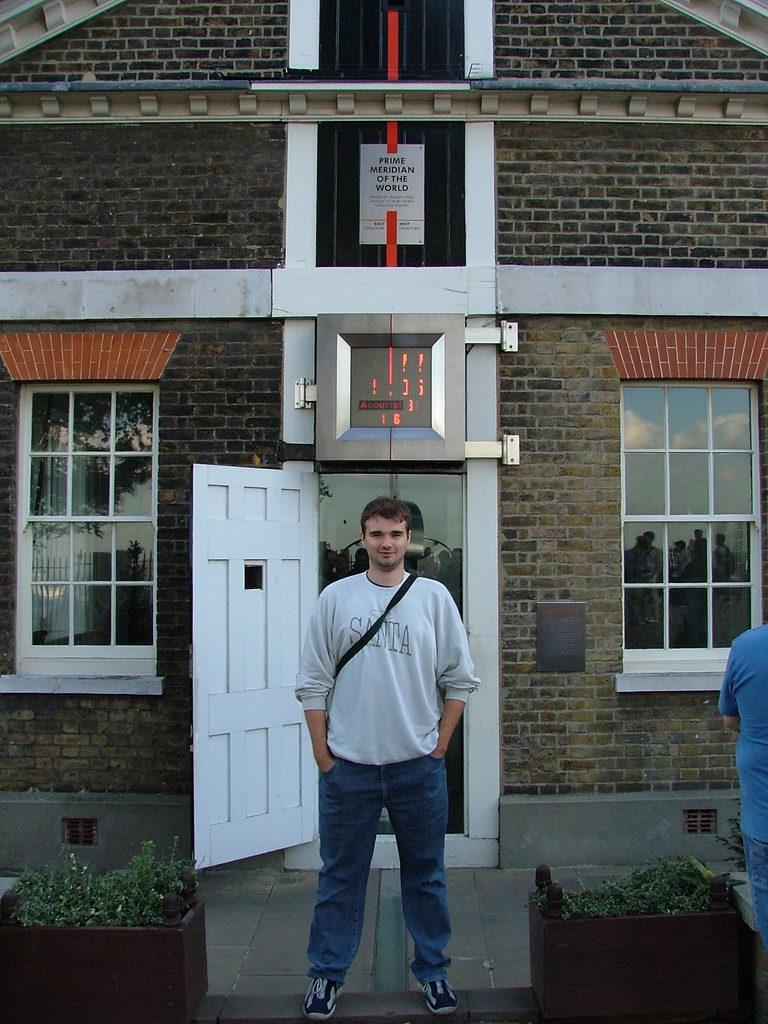<image>
Share a concise interpretation of the image provided. A man wearing a Santa shirt is standing in front of a brick building. 